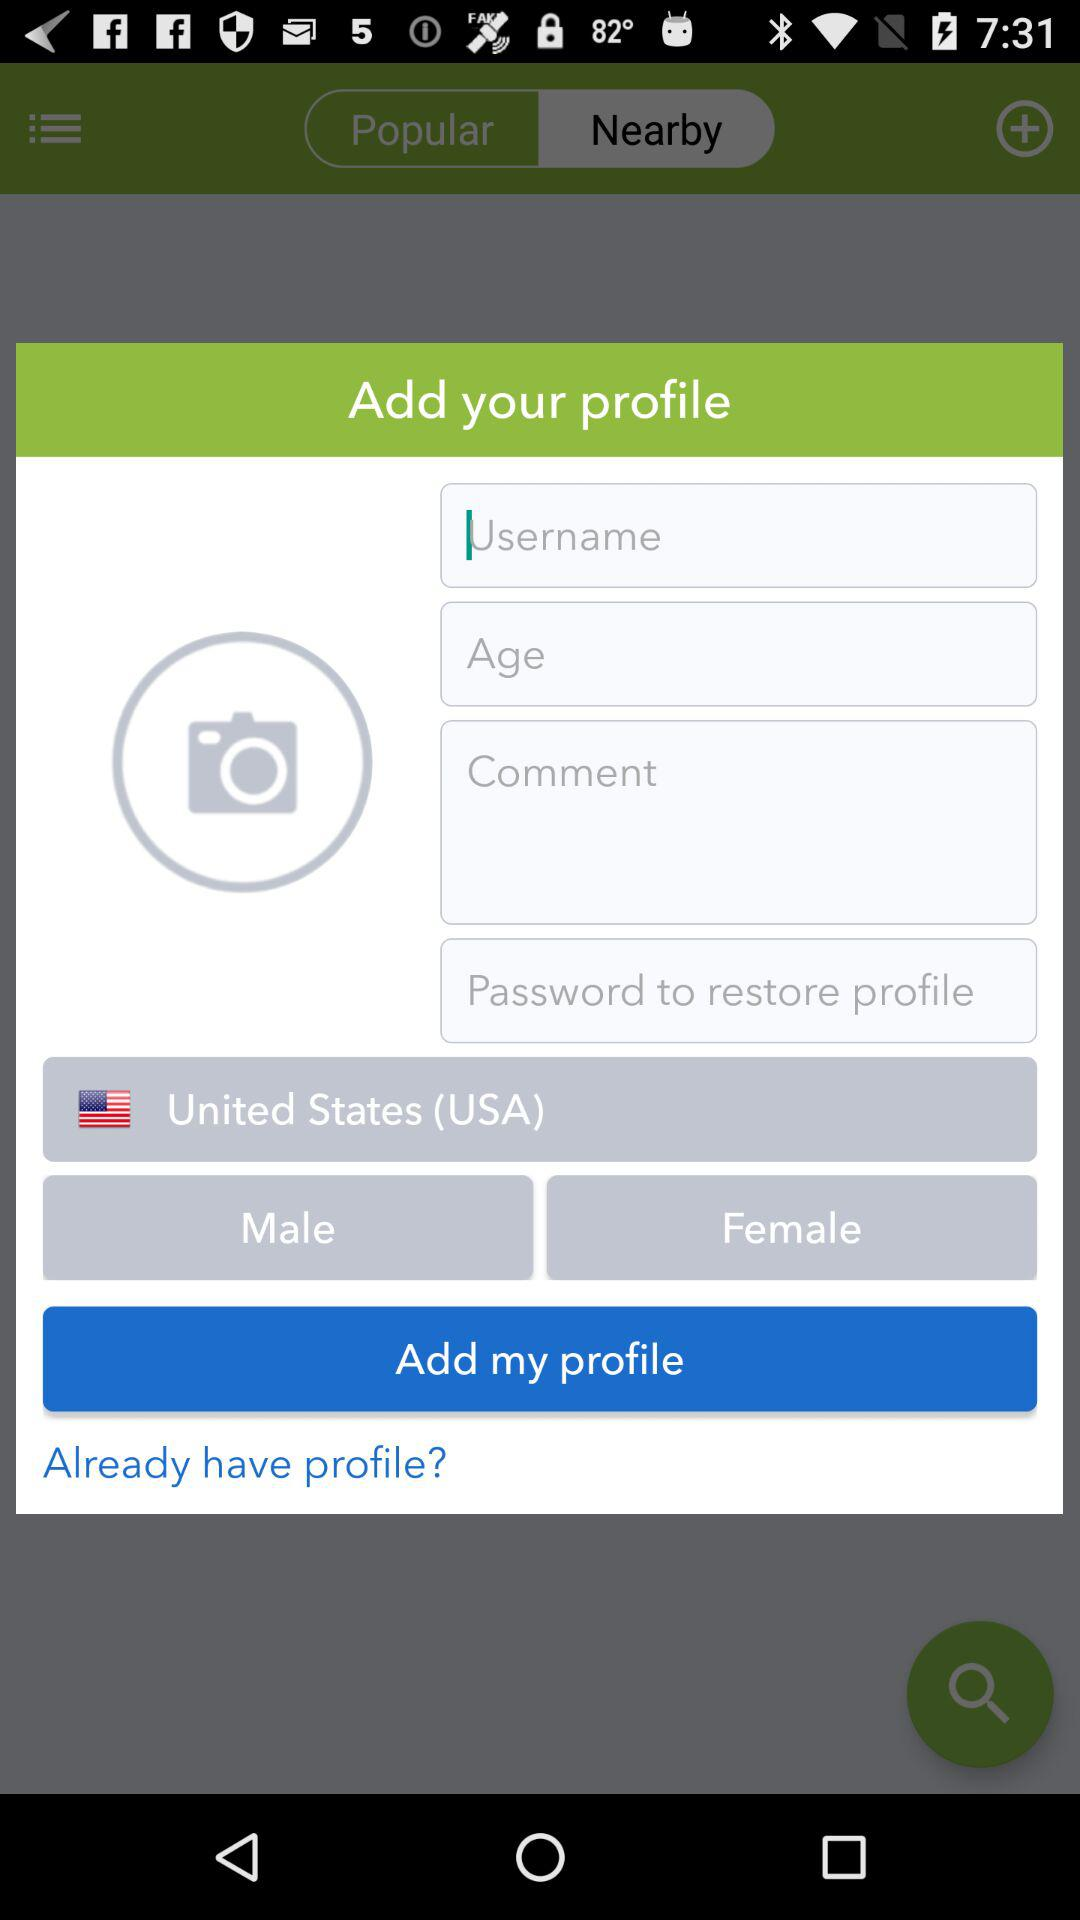Which country is selected? The selected country is the United States (USA). 